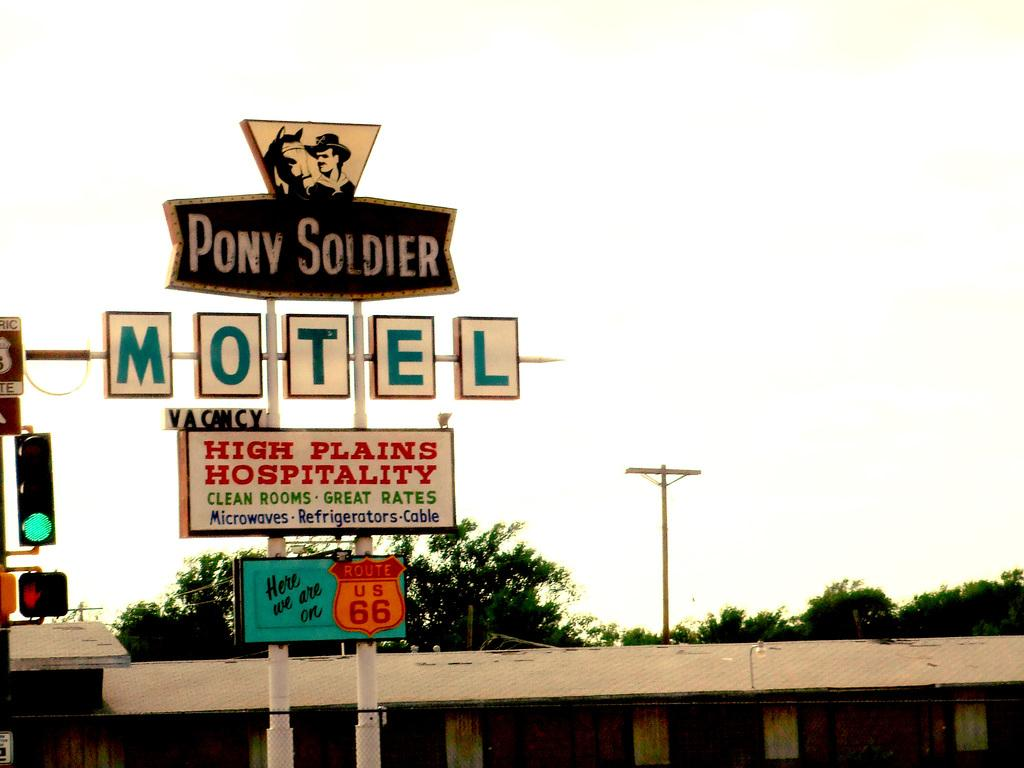<image>
Write a terse but informative summary of the picture. Motel sign that says "Pony Soldier" on top. 